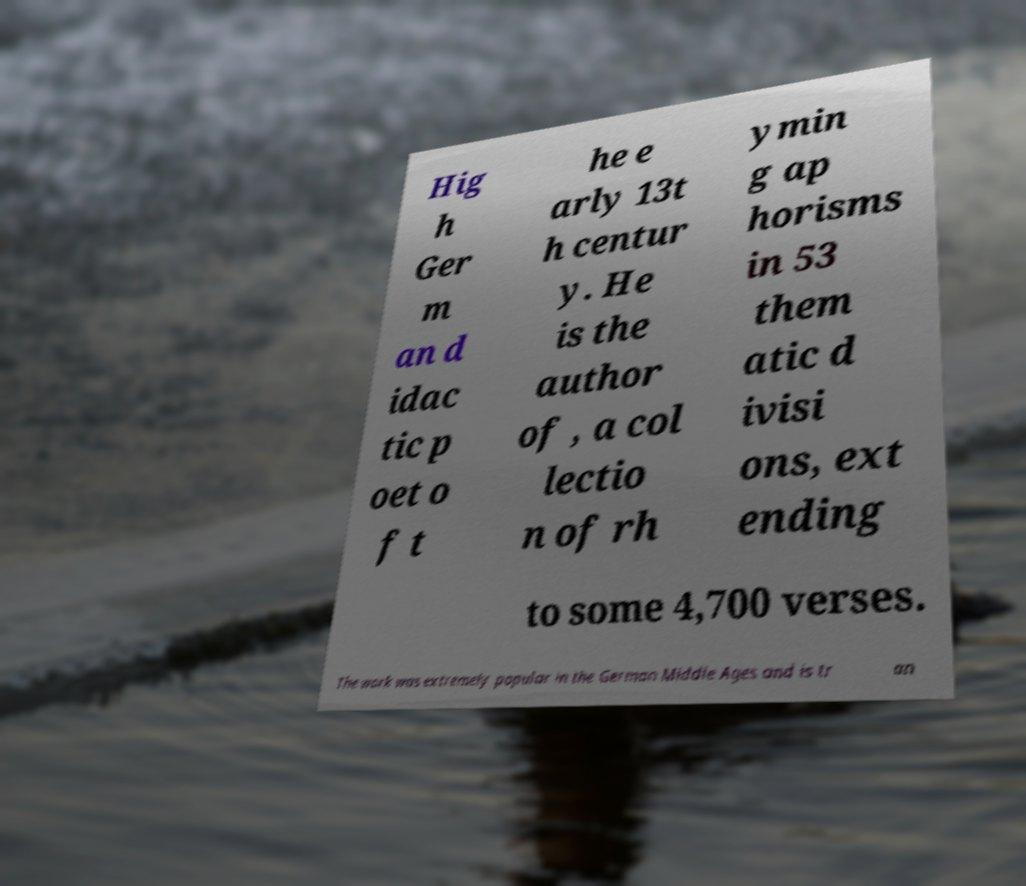Can you accurately transcribe the text from the provided image for me? Hig h Ger m an d idac tic p oet o f t he e arly 13t h centur y. He is the author of , a col lectio n of rh ymin g ap horisms in 53 them atic d ivisi ons, ext ending to some 4,700 verses. The work was extremely popular in the German Middle Ages and is tr an 